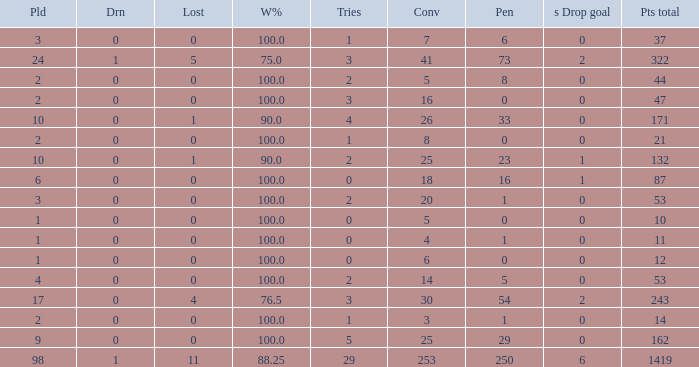How many ties did he have when he had 1 penalties and more than 20 conversions? None. 